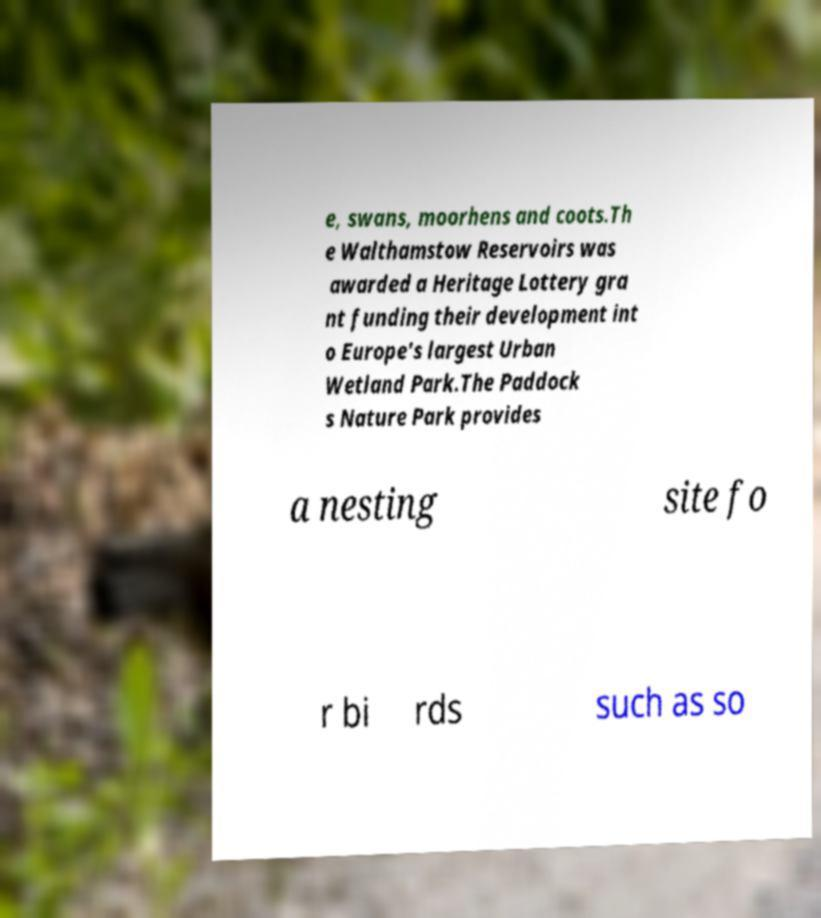Please identify and transcribe the text found in this image. e, swans, moorhens and coots.Th e Walthamstow Reservoirs was awarded a Heritage Lottery gra nt funding their development int o Europe's largest Urban Wetland Park.The Paddock s Nature Park provides a nesting site fo r bi rds such as so 